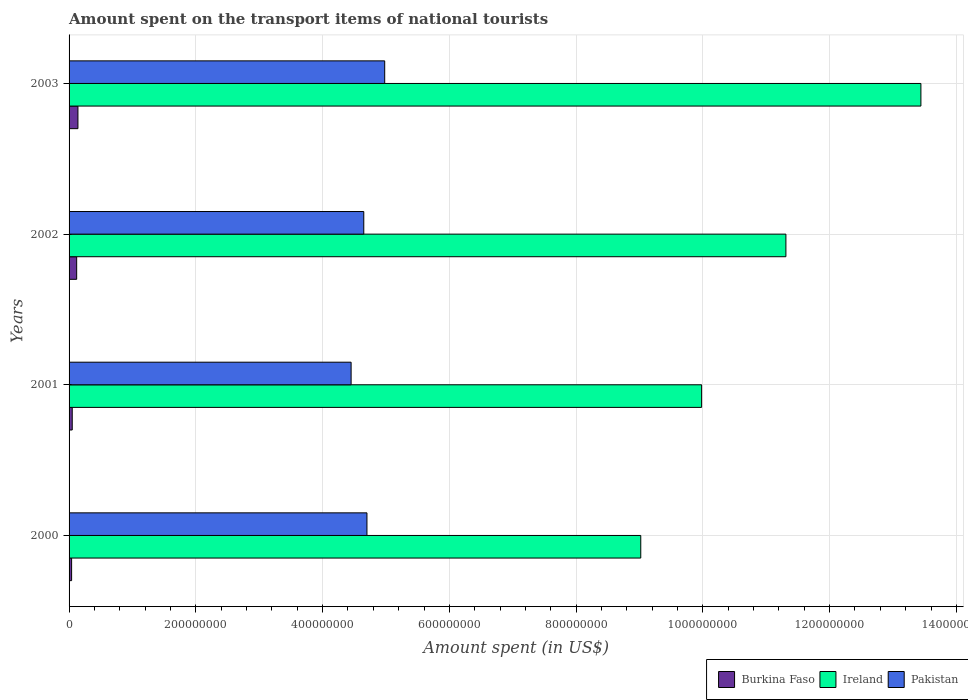Are the number of bars per tick equal to the number of legend labels?
Make the answer very short. Yes. What is the label of the 4th group of bars from the top?
Provide a succinct answer. 2000. In how many cases, is the number of bars for a given year not equal to the number of legend labels?
Offer a very short reply. 0. What is the amount spent on the transport items of national tourists in Burkina Faso in 2001?
Give a very brief answer. 5.00e+06. Across all years, what is the maximum amount spent on the transport items of national tourists in Pakistan?
Your answer should be compact. 4.98e+08. In which year was the amount spent on the transport items of national tourists in Pakistan maximum?
Ensure brevity in your answer.  2003. In which year was the amount spent on the transport items of national tourists in Burkina Faso minimum?
Make the answer very short. 2000. What is the total amount spent on the transport items of national tourists in Burkina Faso in the graph?
Make the answer very short. 3.50e+07. What is the difference between the amount spent on the transport items of national tourists in Pakistan in 2000 and that in 2003?
Offer a terse response. -2.80e+07. What is the difference between the amount spent on the transport items of national tourists in Pakistan in 2000 and the amount spent on the transport items of national tourists in Burkina Faso in 2001?
Offer a very short reply. 4.65e+08. What is the average amount spent on the transport items of national tourists in Pakistan per year?
Your answer should be compact. 4.70e+08. In the year 2001, what is the difference between the amount spent on the transport items of national tourists in Pakistan and amount spent on the transport items of national tourists in Burkina Faso?
Ensure brevity in your answer.  4.40e+08. What is the ratio of the amount spent on the transport items of national tourists in Pakistan in 2001 to that in 2003?
Your response must be concise. 0.89. Is the amount spent on the transport items of national tourists in Pakistan in 2000 less than that in 2002?
Offer a terse response. No. Is the difference between the amount spent on the transport items of national tourists in Pakistan in 2001 and 2002 greater than the difference between the amount spent on the transport items of national tourists in Burkina Faso in 2001 and 2002?
Ensure brevity in your answer.  No. What is the difference between the highest and the second highest amount spent on the transport items of national tourists in Pakistan?
Your answer should be compact. 2.80e+07. In how many years, is the amount spent on the transport items of national tourists in Pakistan greater than the average amount spent on the transport items of national tourists in Pakistan taken over all years?
Your response must be concise. 2. Is the sum of the amount spent on the transport items of national tourists in Burkina Faso in 2000 and 2003 greater than the maximum amount spent on the transport items of national tourists in Ireland across all years?
Keep it short and to the point. No. What does the 3rd bar from the top in 2003 represents?
Your answer should be compact. Burkina Faso. What does the 1st bar from the bottom in 2000 represents?
Make the answer very short. Burkina Faso. Does the graph contain any zero values?
Ensure brevity in your answer.  No. Does the graph contain grids?
Your answer should be very brief. Yes. What is the title of the graph?
Give a very brief answer. Amount spent on the transport items of national tourists. Does "Albania" appear as one of the legend labels in the graph?
Your response must be concise. No. What is the label or title of the X-axis?
Ensure brevity in your answer.  Amount spent (in US$). What is the label or title of the Y-axis?
Offer a terse response. Years. What is the Amount spent (in US$) in Burkina Faso in 2000?
Your answer should be very brief. 4.00e+06. What is the Amount spent (in US$) of Ireland in 2000?
Offer a very short reply. 9.02e+08. What is the Amount spent (in US$) in Pakistan in 2000?
Make the answer very short. 4.70e+08. What is the Amount spent (in US$) in Ireland in 2001?
Make the answer very short. 9.98e+08. What is the Amount spent (in US$) of Pakistan in 2001?
Provide a short and direct response. 4.45e+08. What is the Amount spent (in US$) of Burkina Faso in 2002?
Keep it short and to the point. 1.20e+07. What is the Amount spent (in US$) of Ireland in 2002?
Provide a succinct answer. 1.13e+09. What is the Amount spent (in US$) in Pakistan in 2002?
Your answer should be compact. 4.65e+08. What is the Amount spent (in US$) in Burkina Faso in 2003?
Provide a succinct answer. 1.40e+07. What is the Amount spent (in US$) in Ireland in 2003?
Your answer should be compact. 1.34e+09. What is the Amount spent (in US$) in Pakistan in 2003?
Your answer should be compact. 4.98e+08. Across all years, what is the maximum Amount spent (in US$) in Burkina Faso?
Your answer should be very brief. 1.40e+07. Across all years, what is the maximum Amount spent (in US$) of Ireland?
Ensure brevity in your answer.  1.34e+09. Across all years, what is the maximum Amount spent (in US$) in Pakistan?
Your answer should be very brief. 4.98e+08. Across all years, what is the minimum Amount spent (in US$) in Ireland?
Give a very brief answer. 9.02e+08. Across all years, what is the minimum Amount spent (in US$) of Pakistan?
Give a very brief answer. 4.45e+08. What is the total Amount spent (in US$) in Burkina Faso in the graph?
Provide a succinct answer. 3.50e+07. What is the total Amount spent (in US$) in Ireland in the graph?
Your answer should be very brief. 4.38e+09. What is the total Amount spent (in US$) in Pakistan in the graph?
Make the answer very short. 1.88e+09. What is the difference between the Amount spent (in US$) of Ireland in 2000 and that in 2001?
Give a very brief answer. -9.60e+07. What is the difference between the Amount spent (in US$) in Pakistan in 2000 and that in 2001?
Make the answer very short. 2.50e+07. What is the difference between the Amount spent (in US$) in Burkina Faso in 2000 and that in 2002?
Ensure brevity in your answer.  -8.00e+06. What is the difference between the Amount spent (in US$) of Ireland in 2000 and that in 2002?
Make the answer very short. -2.29e+08. What is the difference between the Amount spent (in US$) of Burkina Faso in 2000 and that in 2003?
Give a very brief answer. -1.00e+07. What is the difference between the Amount spent (in US$) in Ireland in 2000 and that in 2003?
Keep it short and to the point. -4.42e+08. What is the difference between the Amount spent (in US$) of Pakistan in 2000 and that in 2003?
Your response must be concise. -2.80e+07. What is the difference between the Amount spent (in US$) of Burkina Faso in 2001 and that in 2002?
Provide a short and direct response. -7.00e+06. What is the difference between the Amount spent (in US$) of Ireland in 2001 and that in 2002?
Provide a succinct answer. -1.33e+08. What is the difference between the Amount spent (in US$) of Pakistan in 2001 and that in 2002?
Keep it short and to the point. -2.00e+07. What is the difference between the Amount spent (in US$) in Burkina Faso in 2001 and that in 2003?
Give a very brief answer. -9.00e+06. What is the difference between the Amount spent (in US$) of Ireland in 2001 and that in 2003?
Ensure brevity in your answer.  -3.46e+08. What is the difference between the Amount spent (in US$) of Pakistan in 2001 and that in 2003?
Your response must be concise. -5.30e+07. What is the difference between the Amount spent (in US$) in Burkina Faso in 2002 and that in 2003?
Ensure brevity in your answer.  -2.00e+06. What is the difference between the Amount spent (in US$) of Ireland in 2002 and that in 2003?
Your answer should be very brief. -2.13e+08. What is the difference between the Amount spent (in US$) in Pakistan in 2002 and that in 2003?
Offer a terse response. -3.30e+07. What is the difference between the Amount spent (in US$) of Burkina Faso in 2000 and the Amount spent (in US$) of Ireland in 2001?
Keep it short and to the point. -9.94e+08. What is the difference between the Amount spent (in US$) of Burkina Faso in 2000 and the Amount spent (in US$) of Pakistan in 2001?
Offer a terse response. -4.41e+08. What is the difference between the Amount spent (in US$) of Ireland in 2000 and the Amount spent (in US$) of Pakistan in 2001?
Make the answer very short. 4.57e+08. What is the difference between the Amount spent (in US$) of Burkina Faso in 2000 and the Amount spent (in US$) of Ireland in 2002?
Your answer should be very brief. -1.13e+09. What is the difference between the Amount spent (in US$) of Burkina Faso in 2000 and the Amount spent (in US$) of Pakistan in 2002?
Provide a succinct answer. -4.61e+08. What is the difference between the Amount spent (in US$) of Ireland in 2000 and the Amount spent (in US$) of Pakistan in 2002?
Provide a short and direct response. 4.37e+08. What is the difference between the Amount spent (in US$) in Burkina Faso in 2000 and the Amount spent (in US$) in Ireland in 2003?
Ensure brevity in your answer.  -1.34e+09. What is the difference between the Amount spent (in US$) in Burkina Faso in 2000 and the Amount spent (in US$) in Pakistan in 2003?
Your answer should be compact. -4.94e+08. What is the difference between the Amount spent (in US$) of Ireland in 2000 and the Amount spent (in US$) of Pakistan in 2003?
Provide a short and direct response. 4.04e+08. What is the difference between the Amount spent (in US$) of Burkina Faso in 2001 and the Amount spent (in US$) of Ireland in 2002?
Provide a short and direct response. -1.13e+09. What is the difference between the Amount spent (in US$) of Burkina Faso in 2001 and the Amount spent (in US$) of Pakistan in 2002?
Provide a short and direct response. -4.60e+08. What is the difference between the Amount spent (in US$) in Ireland in 2001 and the Amount spent (in US$) in Pakistan in 2002?
Your answer should be compact. 5.33e+08. What is the difference between the Amount spent (in US$) in Burkina Faso in 2001 and the Amount spent (in US$) in Ireland in 2003?
Make the answer very short. -1.34e+09. What is the difference between the Amount spent (in US$) of Burkina Faso in 2001 and the Amount spent (in US$) of Pakistan in 2003?
Offer a very short reply. -4.93e+08. What is the difference between the Amount spent (in US$) in Burkina Faso in 2002 and the Amount spent (in US$) in Ireland in 2003?
Your answer should be compact. -1.33e+09. What is the difference between the Amount spent (in US$) of Burkina Faso in 2002 and the Amount spent (in US$) of Pakistan in 2003?
Keep it short and to the point. -4.86e+08. What is the difference between the Amount spent (in US$) of Ireland in 2002 and the Amount spent (in US$) of Pakistan in 2003?
Keep it short and to the point. 6.33e+08. What is the average Amount spent (in US$) of Burkina Faso per year?
Provide a short and direct response. 8.75e+06. What is the average Amount spent (in US$) of Ireland per year?
Provide a succinct answer. 1.09e+09. What is the average Amount spent (in US$) in Pakistan per year?
Provide a short and direct response. 4.70e+08. In the year 2000, what is the difference between the Amount spent (in US$) of Burkina Faso and Amount spent (in US$) of Ireland?
Make the answer very short. -8.98e+08. In the year 2000, what is the difference between the Amount spent (in US$) in Burkina Faso and Amount spent (in US$) in Pakistan?
Offer a very short reply. -4.66e+08. In the year 2000, what is the difference between the Amount spent (in US$) of Ireland and Amount spent (in US$) of Pakistan?
Give a very brief answer. 4.32e+08. In the year 2001, what is the difference between the Amount spent (in US$) in Burkina Faso and Amount spent (in US$) in Ireland?
Give a very brief answer. -9.93e+08. In the year 2001, what is the difference between the Amount spent (in US$) of Burkina Faso and Amount spent (in US$) of Pakistan?
Your answer should be very brief. -4.40e+08. In the year 2001, what is the difference between the Amount spent (in US$) in Ireland and Amount spent (in US$) in Pakistan?
Make the answer very short. 5.53e+08. In the year 2002, what is the difference between the Amount spent (in US$) of Burkina Faso and Amount spent (in US$) of Ireland?
Give a very brief answer. -1.12e+09. In the year 2002, what is the difference between the Amount spent (in US$) of Burkina Faso and Amount spent (in US$) of Pakistan?
Provide a short and direct response. -4.53e+08. In the year 2002, what is the difference between the Amount spent (in US$) of Ireland and Amount spent (in US$) of Pakistan?
Your response must be concise. 6.66e+08. In the year 2003, what is the difference between the Amount spent (in US$) of Burkina Faso and Amount spent (in US$) of Ireland?
Keep it short and to the point. -1.33e+09. In the year 2003, what is the difference between the Amount spent (in US$) of Burkina Faso and Amount spent (in US$) of Pakistan?
Your response must be concise. -4.84e+08. In the year 2003, what is the difference between the Amount spent (in US$) in Ireland and Amount spent (in US$) in Pakistan?
Make the answer very short. 8.46e+08. What is the ratio of the Amount spent (in US$) in Ireland in 2000 to that in 2001?
Keep it short and to the point. 0.9. What is the ratio of the Amount spent (in US$) of Pakistan in 2000 to that in 2001?
Provide a succinct answer. 1.06. What is the ratio of the Amount spent (in US$) in Ireland in 2000 to that in 2002?
Provide a succinct answer. 0.8. What is the ratio of the Amount spent (in US$) of Pakistan in 2000 to that in 2002?
Offer a very short reply. 1.01. What is the ratio of the Amount spent (in US$) in Burkina Faso in 2000 to that in 2003?
Ensure brevity in your answer.  0.29. What is the ratio of the Amount spent (in US$) in Ireland in 2000 to that in 2003?
Give a very brief answer. 0.67. What is the ratio of the Amount spent (in US$) in Pakistan in 2000 to that in 2003?
Keep it short and to the point. 0.94. What is the ratio of the Amount spent (in US$) of Burkina Faso in 2001 to that in 2002?
Your answer should be compact. 0.42. What is the ratio of the Amount spent (in US$) of Ireland in 2001 to that in 2002?
Offer a very short reply. 0.88. What is the ratio of the Amount spent (in US$) in Pakistan in 2001 to that in 2002?
Offer a very short reply. 0.96. What is the ratio of the Amount spent (in US$) of Burkina Faso in 2001 to that in 2003?
Your answer should be very brief. 0.36. What is the ratio of the Amount spent (in US$) in Ireland in 2001 to that in 2003?
Give a very brief answer. 0.74. What is the ratio of the Amount spent (in US$) of Pakistan in 2001 to that in 2003?
Provide a short and direct response. 0.89. What is the ratio of the Amount spent (in US$) in Burkina Faso in 2002 to that in 2003?
Offer a terse response. 0.86. What is the ratio of the Amount spent (in US$) in Ireland in 2002 to that in 2003?
Your answer should be compact. 0.84. What is the ratio of the Amount spent (in US$) in Pakistan in 2002 to that in 2003?
Your answer should be compact. 0.93. What is the difference between the highest and the second highest Amount spent (in US$) in Burkina Faso?
Make the answer very short. 2.00e+06. What is the difference between the highest and the second highest Amount spent (in US$) of Ireland?
Your answer should be compact. 2.13e+08. What is the difference between the highest and the second highest Amount spent (in US$) in Pakistan?
Provide a succinct answer. 2.80e+07. What is the difference between the highest and the lowest Amount spent (in US$) in Burkina Faso?
Your response must be concise. 1.00e+07. What is the difference between the highest and the lowest Amount spent (in US$) in Ireland?
Provide a succinct answer. 4.42e+08. What is the difference between the highest and the lowest Amount spent (in US$) of Pakistan?
Offer a very short reply. 5.30e+07. 